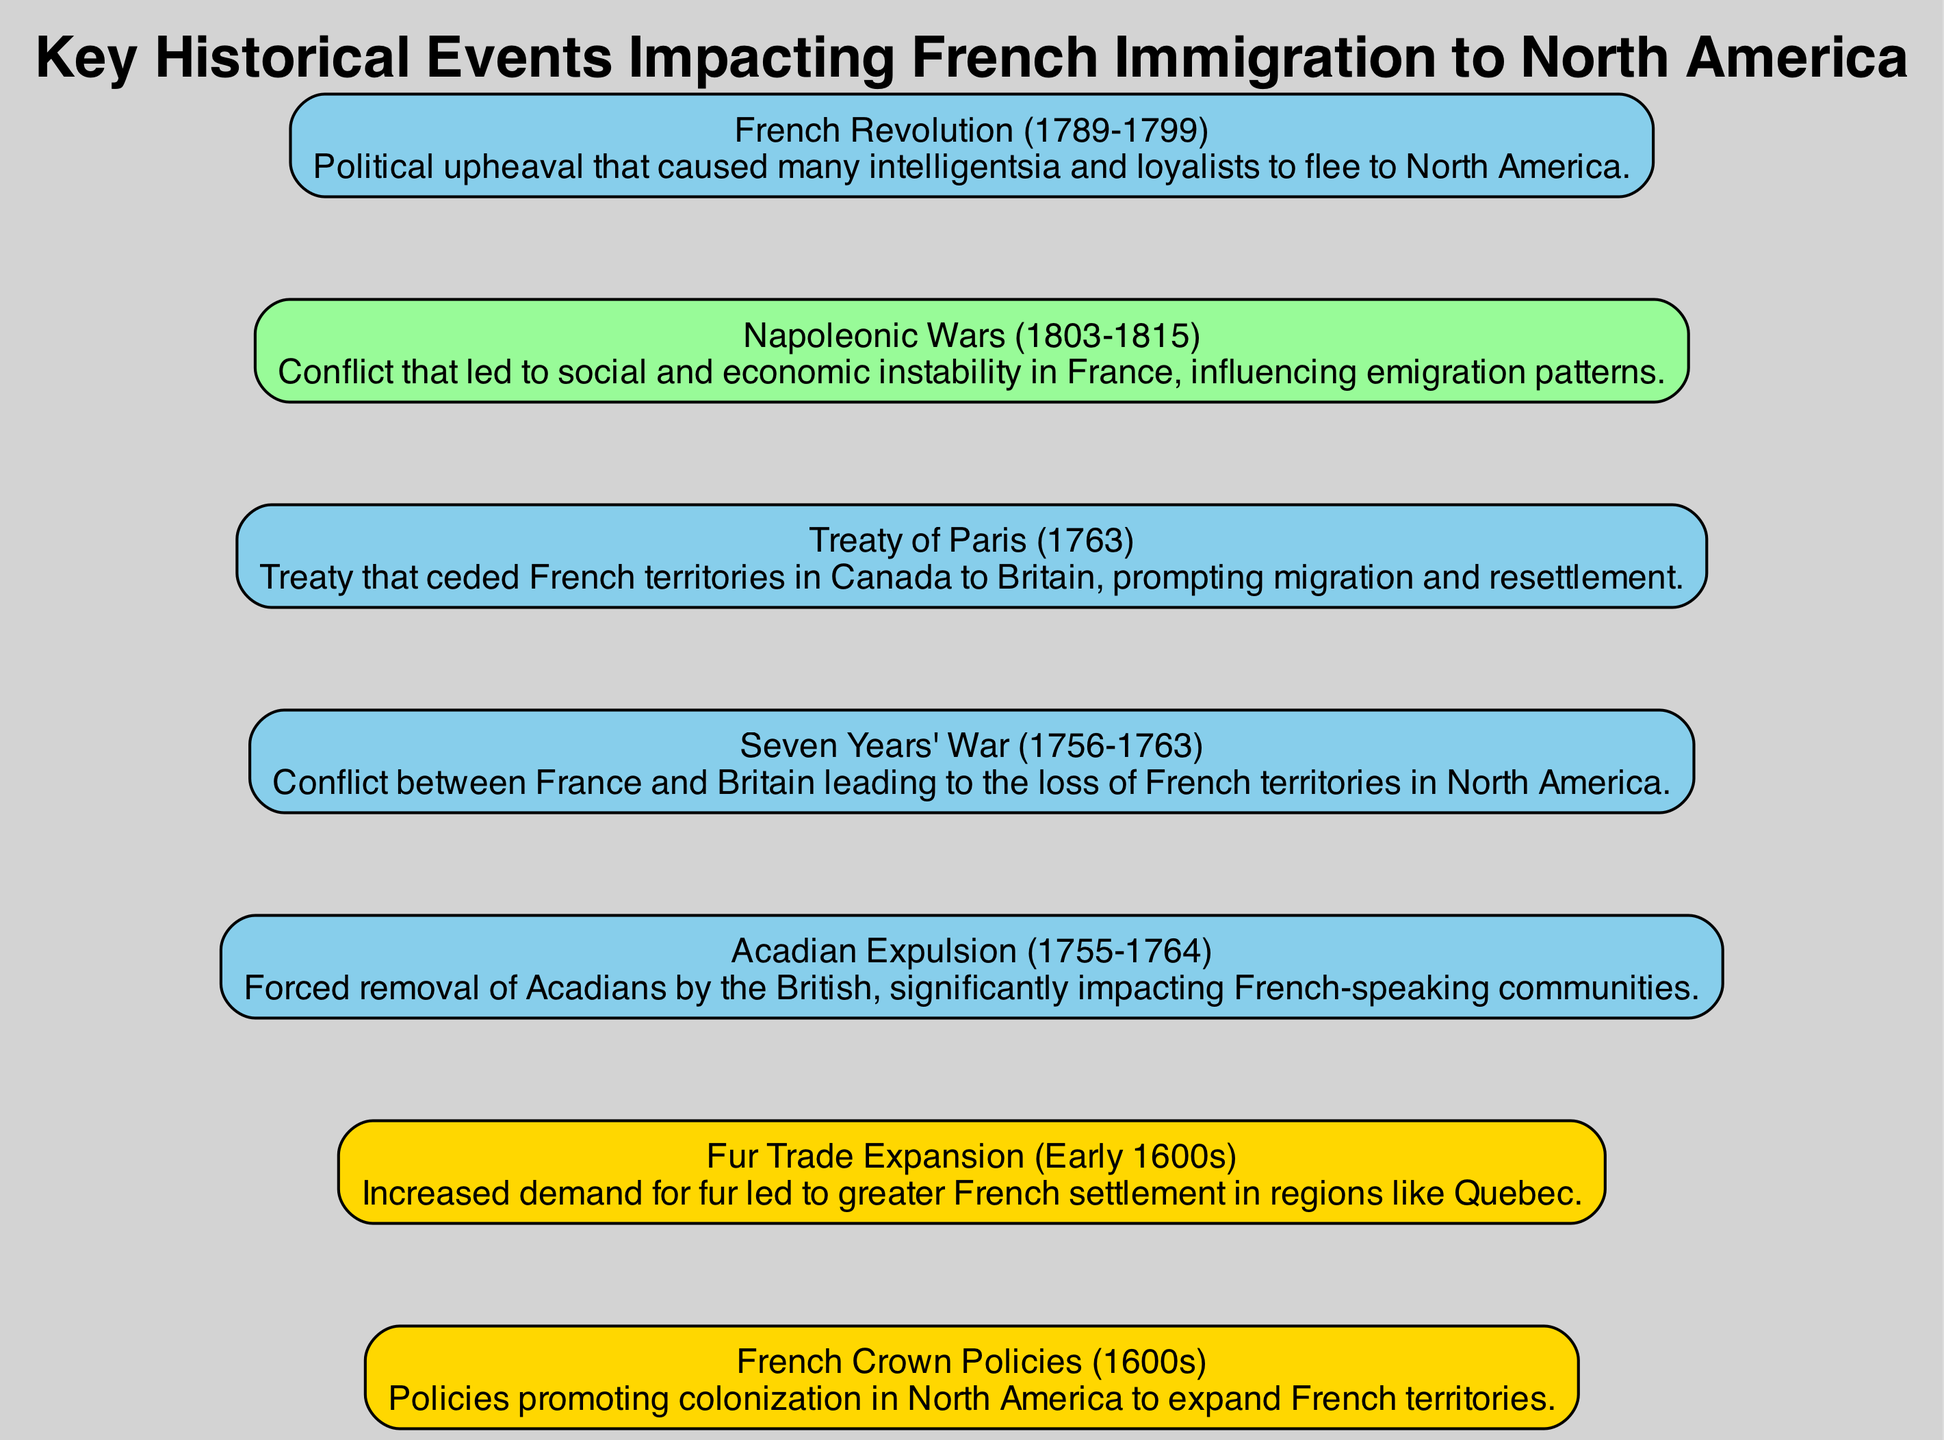What is the first node in the diagram? The diagram starts with "French Crown Policies (1600s)", which is the first historical event listed and represents the beginning of French immigration policies.
Answer: French Crown Policies (1600s) How many nodes are present in the diagram? By counting the individual historical events listed in the data provided, there are a total of seven nodes represented in the diagram.
Answer: 7 Which event represents the forced removal of Acadians? The event titled "Acadian Expulsion (1755-1764)" directly describes the forced removal of the Acadians by the British, clearly stated in its description.
Answer: Acadian Expulsion (1755-1764) What conflict led to the loss of French territories in North America? The "Seven Years' War (1756-1763)" is the conflict that resulted in significant territorial losses for France in North America, as indicated in its description.
Answer: Seven Years' War (1756-1763) Which two events are connected chronologically in the diagram? "Treaty of Paris (1763)" comes after the "Seven Years' War (1756-1763)" in the timeline and is connected to it, signifying the outcome of that conflict which influenced territorial changes.
Answer: Seven Years' War (1756-1763) and Treaty of Paris (1763) How does the French Revolution impact migration patterns? The "French Revolution (1789-1799)" led many individuals, particularly the intelligentsia and loyalists, to migrate to North America due to political upheaval, highlighting the social consequences of the revolution.
Answer: French Revolution (1789-1799) What time period is associated with the "Fur Trade Expansion"? The "Fur Trade Expansion (Early 1600s)" is categorized within the early part of the 17th century, which falls within the 1600s timeline context of the diagram.
Answer: Early 1600s Which event signifies the beginning of significant French emigration due to political unrest? The "French Revolution (1789-1799)" marks a notable point of upheaval that primarily contributed to significant emigration from France to North America, driven by instability and fear.
Answer: French Revolution (1789-1799) 